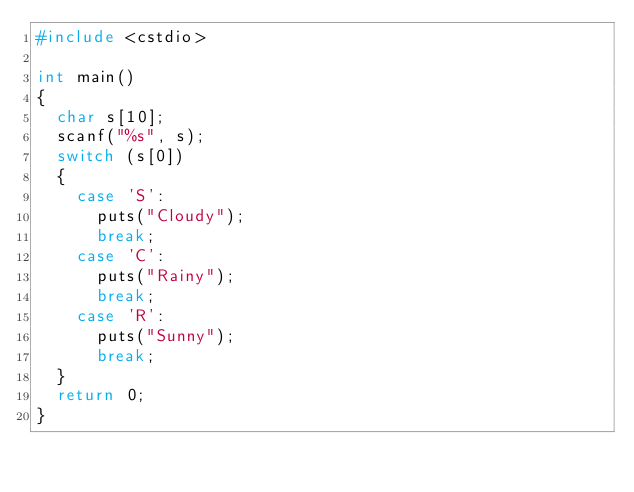Convert code to text. <code><loc_0><loc_0><loc_500><loc_500><_C++_>#include <cstdio>

int main()
{
  char s[10];
  scanf("%s", s);
  switch (s[0])
  {
    case 'S':
      puts("Cloudy");
      break;
    case 'C':
      puts("Rainy");
      break;
    case 'R':
      puts("Sunny");
      break;
  }
  return 0;
}</code> 